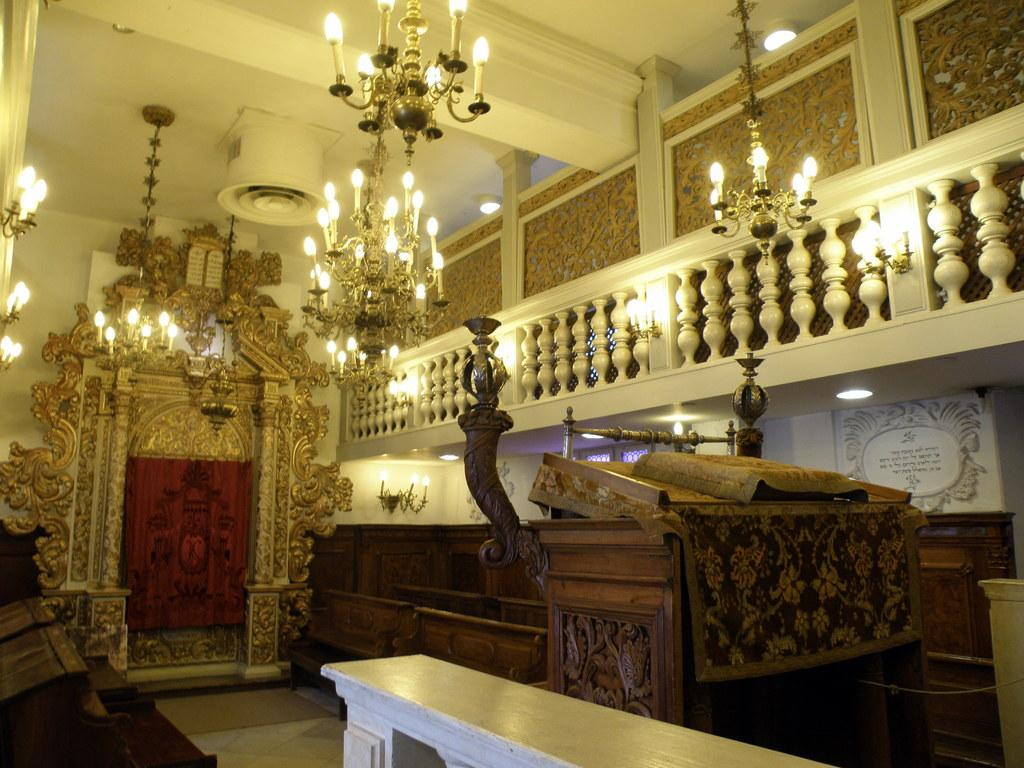What is located in the center of the image? There is a wall in the center of the image. What is above the wall in the image? There is a roof in the image. What is located around the wall in the image? There is a fence in the image. What is written or displayed on the wall or board in the image? There is a board with text in the image. What type of objects can be seen in the image? There are wooden objects and chandeliers in the image. Are there any other objects or features in the image? Yes, there are other objects in the image. What design or pattern is visible on the wall? There is a design on the wall in the image. Can you hear the bells ringing in the image? There are no bells present in the image, so it is not possible to hear them ringing. 